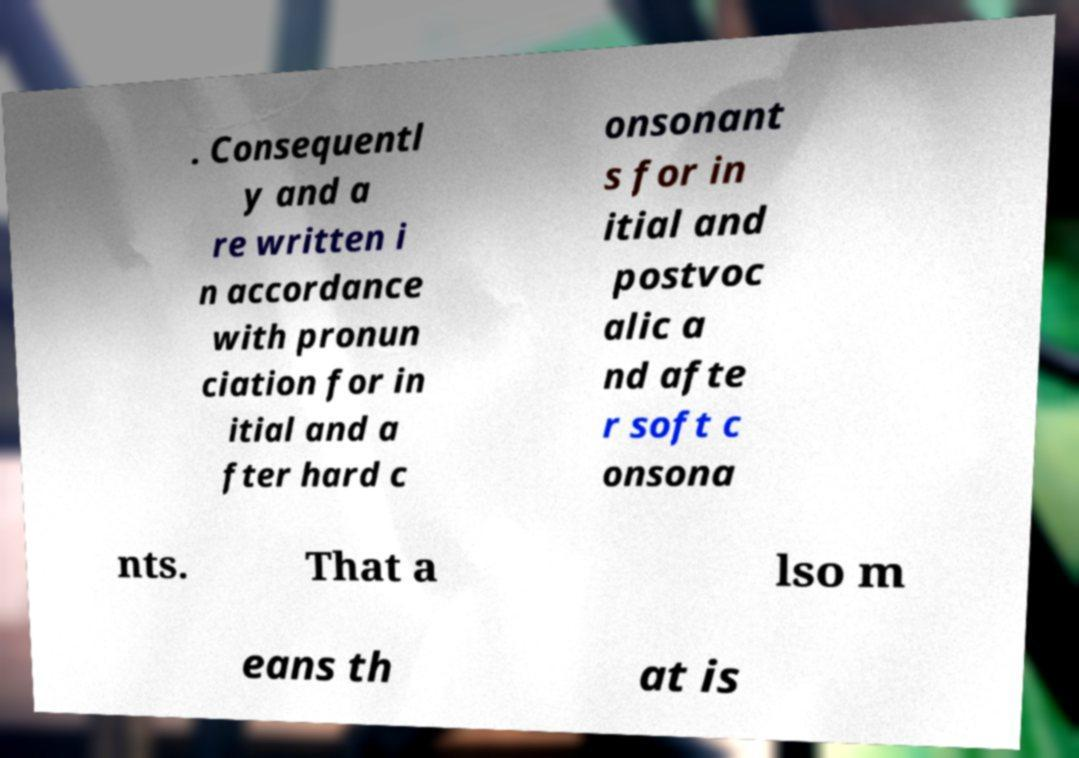Can you read and provide the text displayed in the image?This photo seems to have some interesting text. Can you extract and type it out for me? . Consequentl y and a re written i n accordance with pronun ciation for in itial and a fter hard c onsonant s for in itial and postvoc alic a nd afte r soft c onsona nts. That a lso m eans th at is 